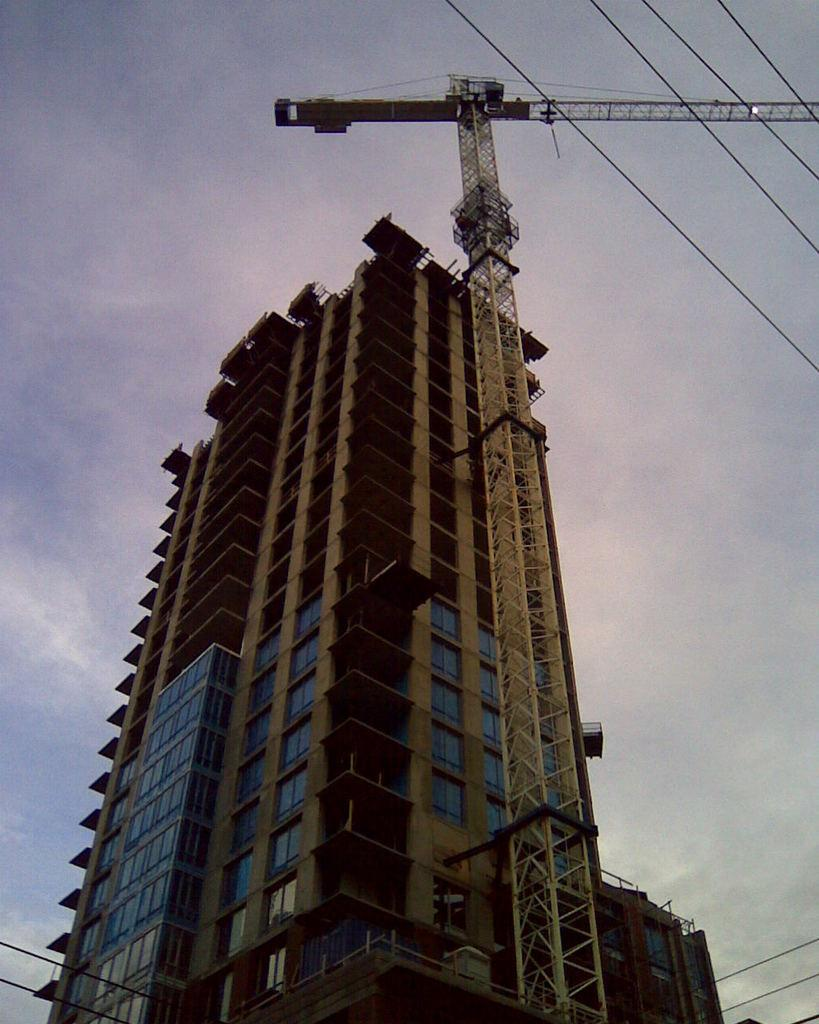What type of structure is visible in the image? There is a building in the image. What is the purpose of the large machine near the building? There is a construction crane in the image, which is used for lifting and moving heavy materials during construction. How would you describe the weather based on the image? The sky is cloudy in the image, suggesting a potentially overcast or cloudy day. What type of cub is playing with the band in the image? There is no cub or band present in the image; it only features a building and a construction crane. 